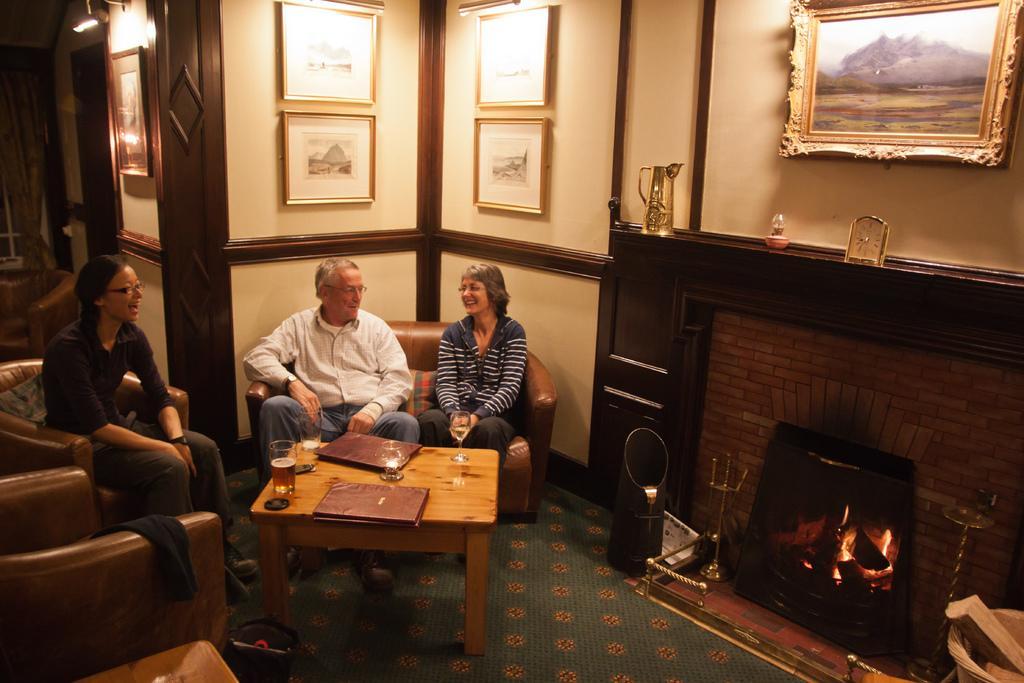Describe this image in one or two sentences. In this image i can see two women and a man sitting in a couch there are three glasses and two books on a table at the right side there is a fire,at the background there are few frames attached to a wall. 